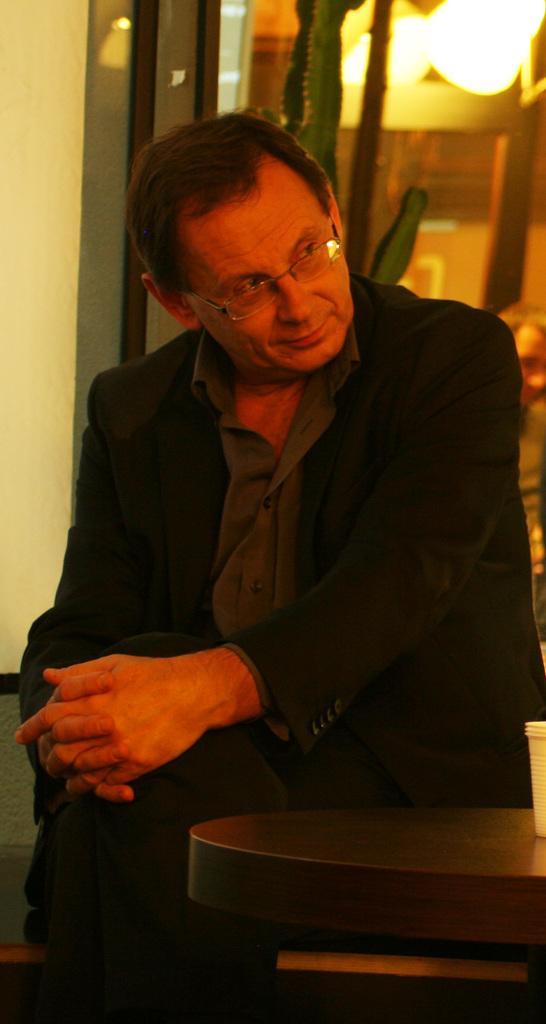Please provide a concise description of this image. a person is sitting wearing black suit. in front of him there is a wooden table on which there is a glass. at the left back there is a wall and it the right back there are lights on the top. 